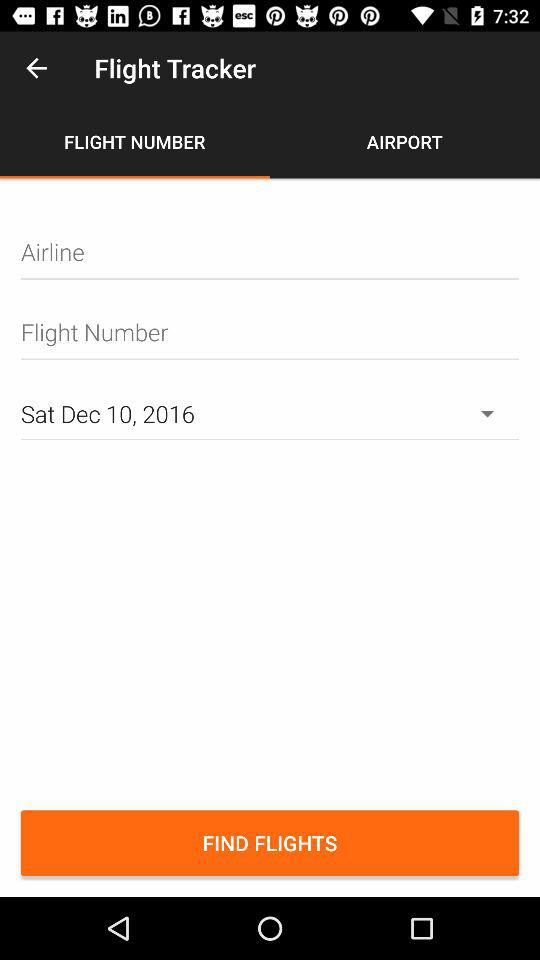How many days in the future are the flights shown?
Answer the question using a single word or phrase. 1 